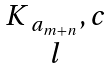<formula> <loc_0><loc_0><loc_500><loc_500>\begin{matrix} K _ { \ a _ { m + n } } , c \\ l \end{matrix}</formula> 